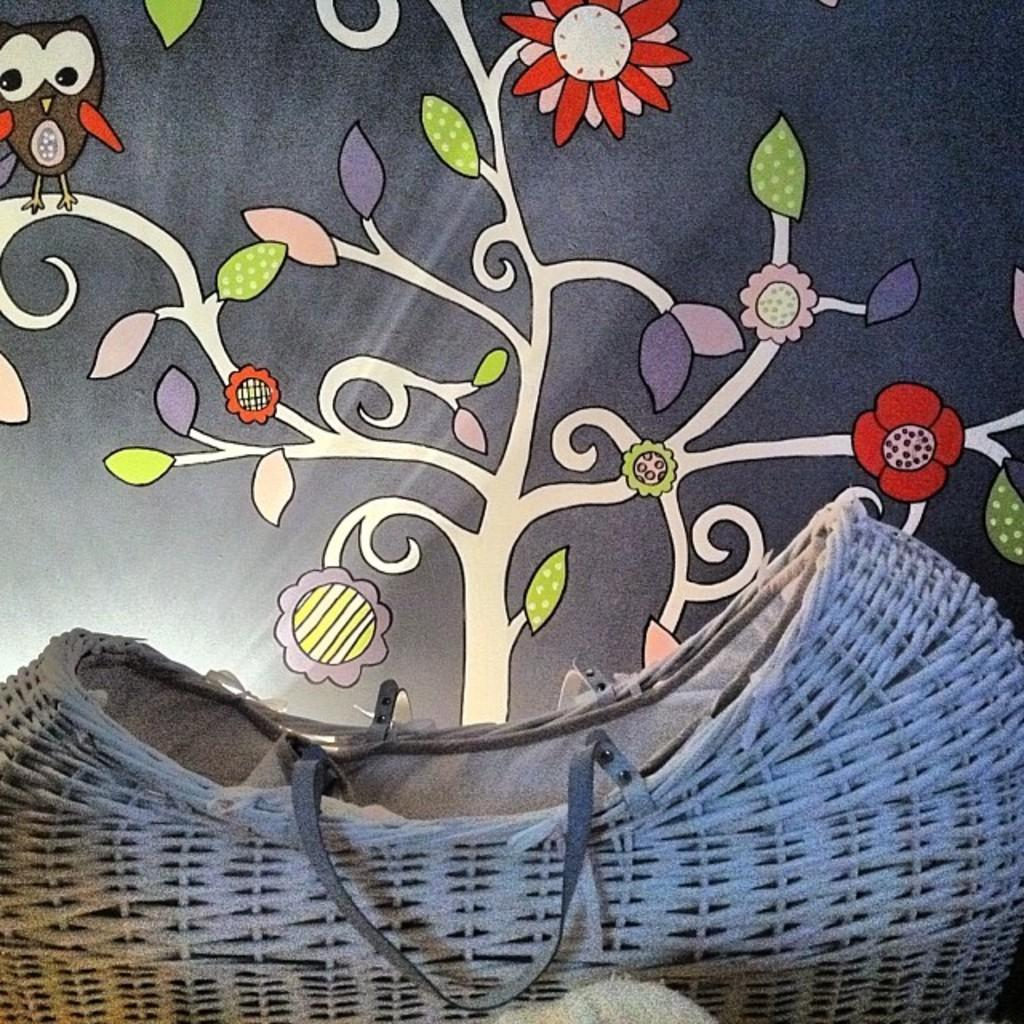What is located in the front of the image? There is a basket in the front of the image. What can be seen in the background of the image? There is a wall in the background of the image. What is on the wall in the background? There is a painting on the wall in the background. How many worms can be seen crawling on the painting in the image? There are no worms present in the image, and therefore no such activity can be observed. 